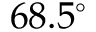<formula> <loc_0><loc_0><loc_500><loc_500>6 8 . 5 ^ { \circ }</formula> 